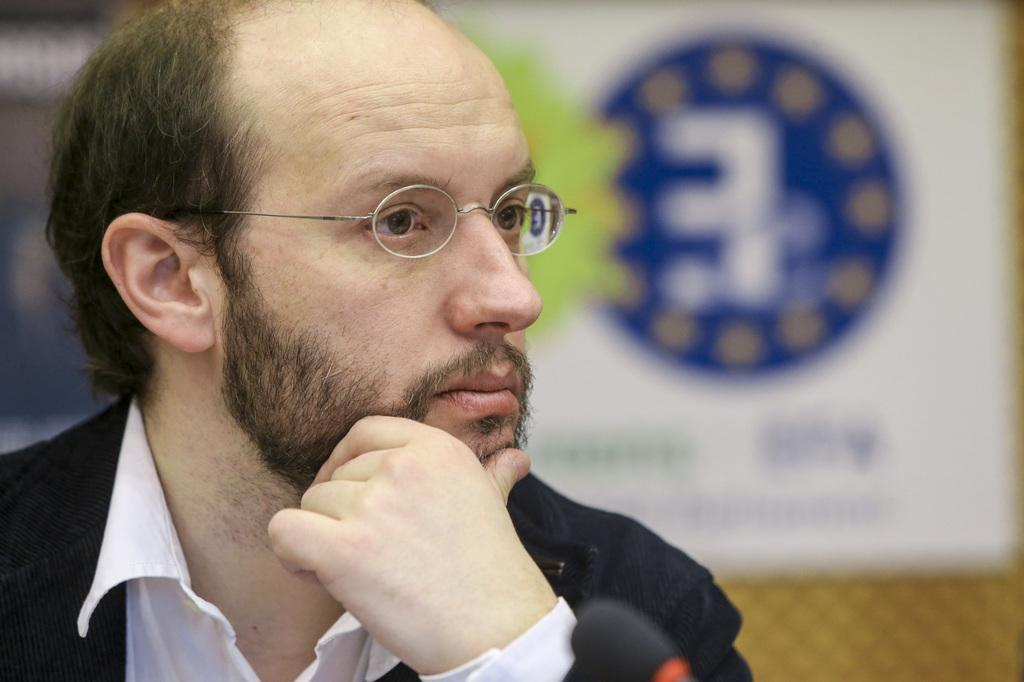Who is present in the image? There is a man in the image. On which side of the image is the man located? The man is on the left side of the image. What is the man wearing on his upper body? The man is wearing a shirt and a coat. What accessory is the man wearing on his face? The man is wearing spectacles. How many geese are flying over the man in the image? There are no geese present in the image. What type of lift is being used by the man in the image? The man is not using any lift in the image; he is standing on the ground. 